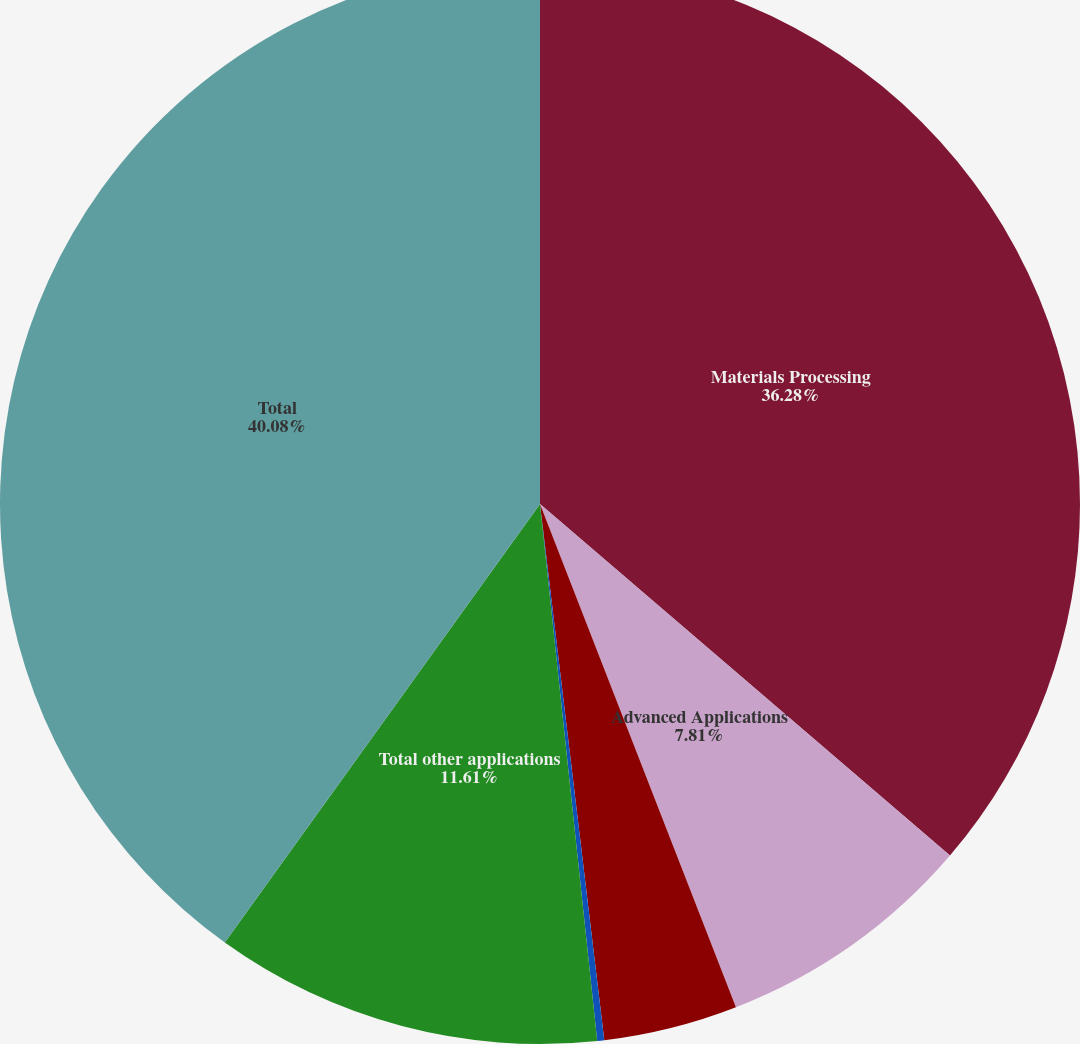<chart> <loc_0><loc_0><loc_500><loc_500><pie_chart><fcel>Materials Processing<fcel>Advanced Applications<fcel>Communications<fcel>Medical<fcel>Total other applications<fcel>Total<nl><fcel>36.28%<fcel>7.81%<fcel>4.01%<fcel>0.21%<fcel>11.61%<fcel>40.08%<nl></chart> 